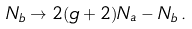<formula> <loc_0><loc_0><loc_500><loc_500>N _ { b } \rightarrow 2 ( g + 2 ) N _ { a } - N _ { b } \, .</formula> 